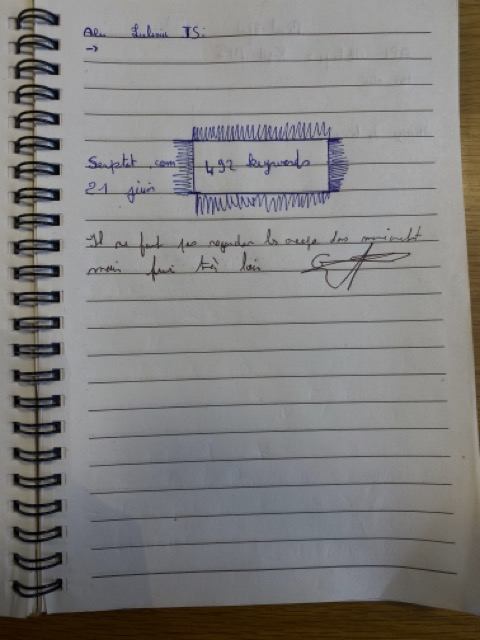Is there a handwritten signature in the image? Yes, there is a handwritten signature in the image located towards the bottom right of the page. 